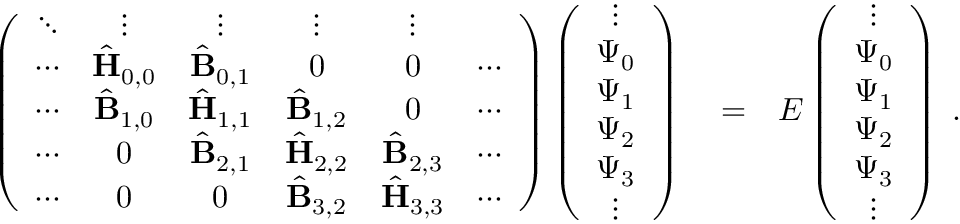<formula> <loc_0><loc_0><loc_500><loc_500>\begin{array} { r l r } { \left ( \begin{array} { c c c c c c } { \ddots } & { \vdots } & { \vdots } & { \vdots } & { \vdots } \\ { \cdots } & { \hat { H } _ { 0 , 0 } } & { \hat { B } _ { 0 , 1 } } & { 0 } & { 0 } & { \cdots } \\ { \cdots } & { \hat { B } _ { 1 , 0 } } & { \hat { H } _ { 1 , 1 } } & { \hat { B } _ { 1 , 2 } } & { 0 } & { \cdots } \\ { \cdots } & { 0 } & { \hat { B } _ { 2 , 1 } } & { \hat { H } _ { 2 , 2 } } & { \hat { B } _ { 2 , 3 } } & { \cdots } \\ { \cdots } & { 0 } & { 0 } & { \hat { B } _ { 3 , 2 } } & { \hat { H } _ { 3 , 3 } } & { \cdots } \end{array} \right ) \left ( \begin{array} { c } { \vdots } \\ { \Psi _ { 0 } } \\ { \Psi _ { 1 } } \\ { \Psi _ { 2 } } \\ { \Psi _ { 3 } } \\ { \vdots } \end{array} \right ) } & = } & { E \left ( \begin{array} { c } { \vdots } \\ { \Psi _ { 0 } } \\ { \Psi _ { 1 } } \\ { \Psi _ { 2 } } \\ { \Psi _ { 3 } } \\ { \vdots } \end{array} \right ) \, . } \end{array}</formula> 